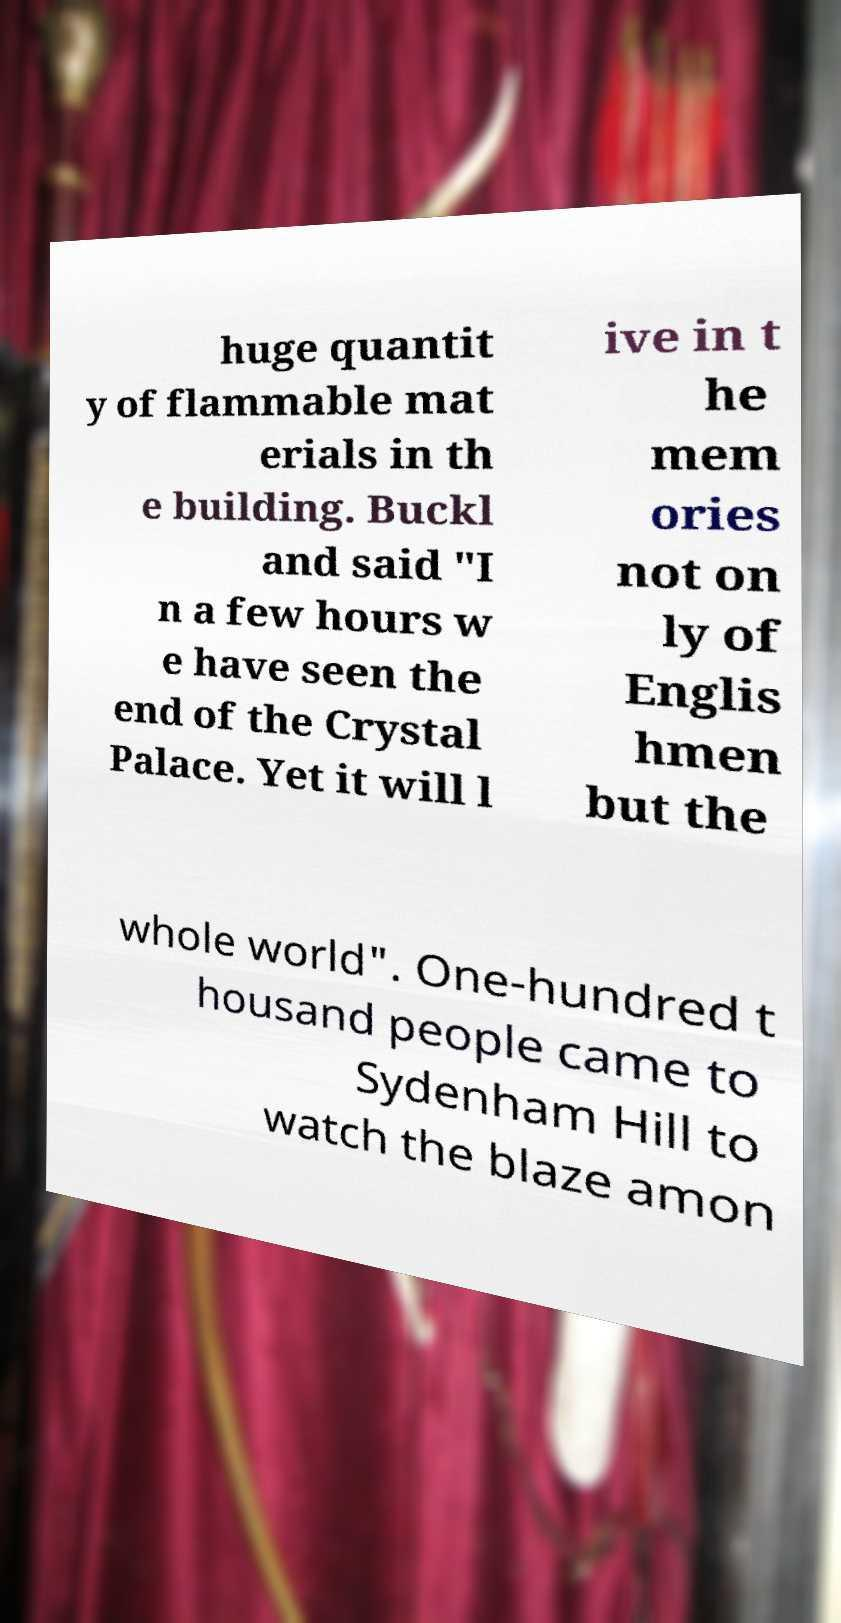Can you accurately transcribe the text from the provided image for me? huge quantit y of flammable mat erials in th e building. Buckl and said "I n a few hours w e have seen the end of the Crystal Palace. Yet it will l ive in t he mem ories not on ly of Englis hmen but the whole world". One-hundred t housand people came to Sydenham Hill to watch the blaze amon 